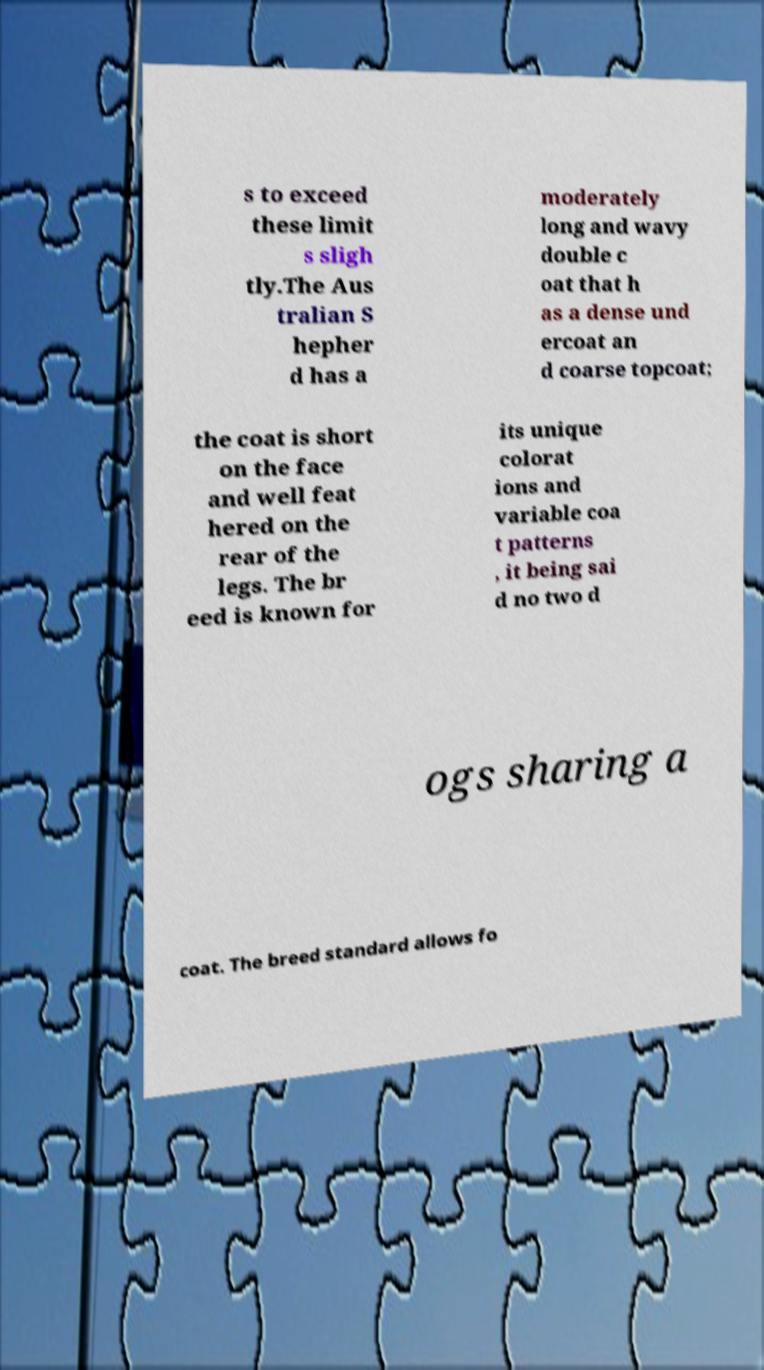Could you assist in decoding the text presented in this image and type it out clearly? s to exceed these limit s sligh tly.The Aus tralian S hepher d has a moderately long and wavy double c oat that h as a dense und ercoat an d coarse topcoat; the coat is short on the face and well feat hered on the rear of the legs. The br eed is known for its unique colorat ions and variable coa t patterns , it being sai d no two d ogs sharing a coat. The breed standard allows fo 